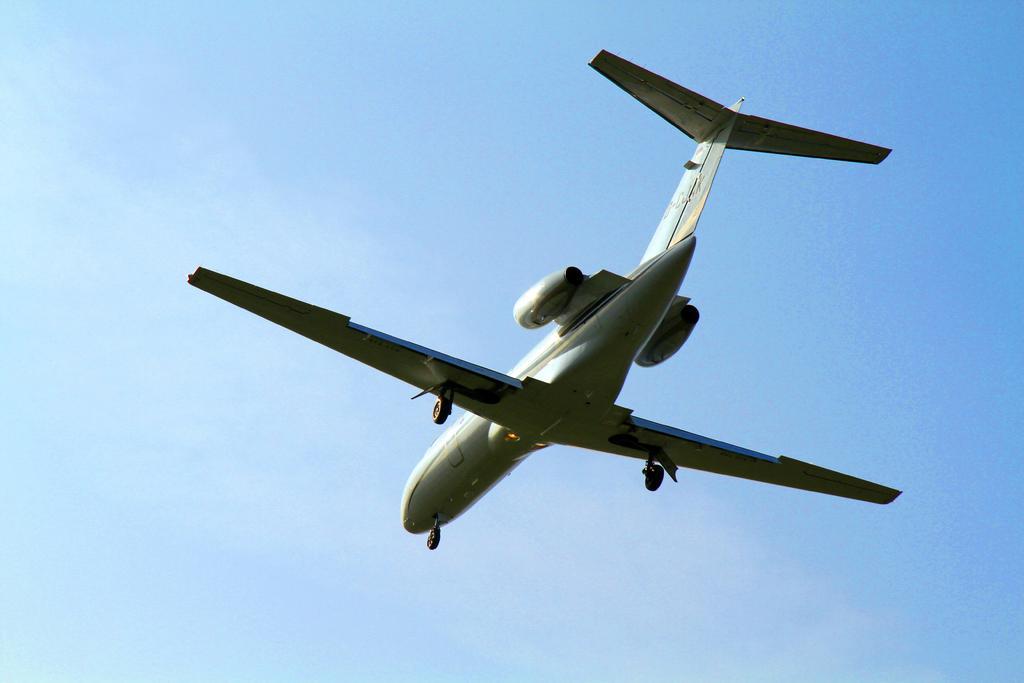Could you give a brief overview of what you see in this image? In this image we can see an airplane. In the background there is sky. 